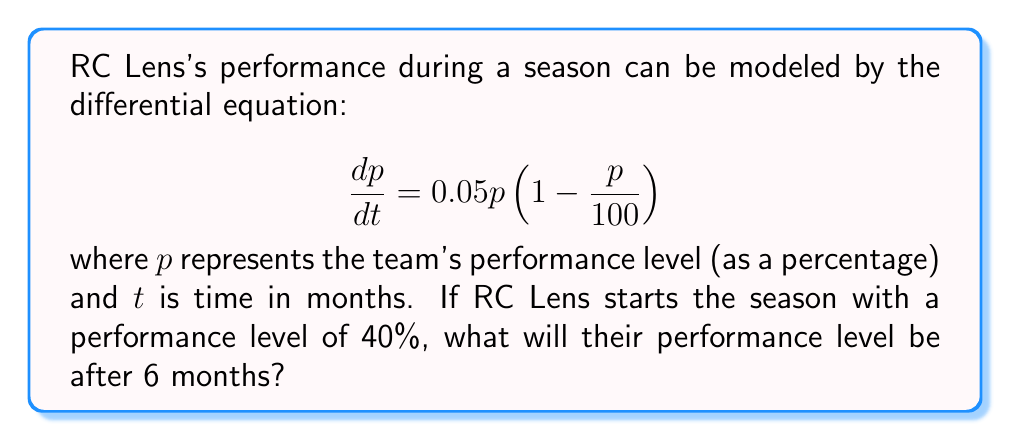Provide a solution to this math problem. To solve this problem, we need to use the method for solving separable differential equations:

1) First, rewrite the equation in separable form:
   $$\frac{dp}{p(1 - \frac{p}{100})} = 0.05dt$$

2) Integrate both sides:
   $$\int \frac{dp}{p(1 - \frac{p}{100})} = \int 0.05dt$$

3) The left side can be integrated using partial fractions:
   $$\int (\frac{1}{p} + \frac{1}{100-p})dp = 0.05t + C$$

4) After integration:
   $$\ln|p| - \ln|100-p| = 0.05t + C$$

5) Simplify:
   $$\ln|\frac{p}{100-p}| = 0.05t + C$$

6) Exponentiate both sides:
   $$\frac{p}{100-p} = Ae^{0.05t}$$, where $A = e^C$

7) Solve for $p$:
   $$p = \frac{100Ae^{0.05t}}{1 + Ae^{0.05t}}$$

8) Use the initial condition $p(0) = 40$ to find $A$:
   $$40 = \frac{100A}{1 + A}$$
   $$A = \frac{2}{3}$$

9) The final solution is:
   $$p = \frac{100(\frac{2}{3})e^{0.05t}}{1 + (\frac{2}{3})e^{0.05t}}$$

10) To find $p(6)$, substitute $t=6$:
    $$p(6) = \frac{100(\frac{2}{3})e^{0.3}}{1 + (\frac{2}{3})e^{0.3}} \approx 62.31$$
Answer: After 6 months, RC Lens's performance level will be approximately 62.31%. 